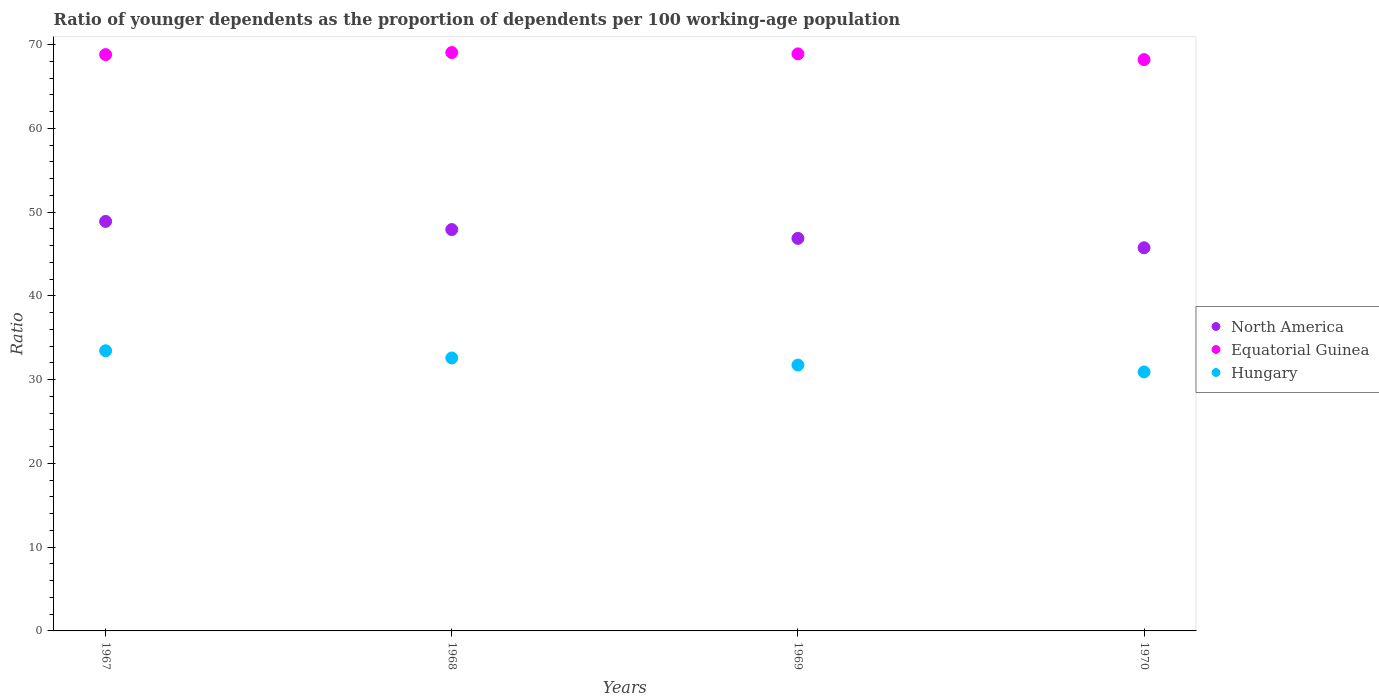How many different coloured dotlines are there?
Offer a very short reply. 3. Is the number of dotlines equal to the number of legend labels?
Ensure brevity in your answer.  Yes. What is the age dependency ratio(young) in North America in 1967?
Make the answer very short. 48.89. Across all years, what is the maximum age dependency ratio(young) in Equatorial Guinea?
Ensure brevity in your answer.  69.04. Across all years, what is the minimum age dependency ratio(young) in Equatorial Guinea?
Offer a very short reply. 68.2. In which year was the age dependency ratio(young) in Equatorial Guinea maximum?
Your response must be concise. 1968. What is the total age dependency ratio(young) in North America in the graph?
Provide a succinct answer. 189.4. What is the difference between the age dependency ratio(young) in Equatorial Guinea in 1967 and that in 1970?
Provide a succinct answer. 0.6. What is the difference between the age dependency ratio(young) in Equatorial Guinea in 1968 and the age dependency ratio(young) in North America in 1970?
Offer a terse response. 23.3. What is the average age dependency ratio(young) in North America per year?
Give a very brief answer. 47.35. In the year 1969, what is the difference between the age dependency ratio(young) in Equatorial Guinea and age dependency ratio(young) in North America?
Give a very brief answer. 22.03. In how many years, is the age dependency ratio(young) in Hungary greater than 62?
Your response must be concise. 0. What is the ratio of the age dependency ratio(young) in North America in 1968 to that in 1970?
Ensure brevity in your answer.  1.05. Is the difference between the age dependency ratio(young) in Equatorial Guinea in 1968 and 1970 greater than the difference between the age dependency ratio(young) in North America in 1968 and 1970?
Make the answer very short. No. What is the difference between the highest and the second highest age dependency ratio(young) in Hungary?
Offer a terse response. 0.86. What is the difference between the highest and the lowest age dependency ratio(young) in North America?
Offer a very short reply. 3.15. Is it the case that in every year, the sum of the age dependency ratio(young) in North America and age dependency ratio(young) in Hungary  is greater than the age dependency ratio(young) in Equatorial Guinea?
Ensure brevity in your answer.  Yes. Is the age dependency ratio(young) in Equatorial Guinea strictly greater than the age dependency ratio(young) in North America over the years?
Provide a succinct answer. Yes. Is the age dependency ratio(young) in Equatorial Guinea strictly less than the age dependency ratio(young) in North America over the years?
Ensure brevity in your answer.  No. Does the graph contain grids?
Offer a very short reply. No. Where does the legend appear in the graph?
Your answer should be very brief. Center right. What is the title of the graph?
Offer a very short reply. Ratio of younger dependents as the proportion of dependents per 100 working-age population. What is the label or title of the X-axis?
Ensure brevity in your answer.  Years. What is the label or title of the Y-axis?
Your answer should be very brief. Ratio. What is the Ratio in North America in 1967?
Provide a succinct answer. 48.89. What is the Ratio in Equatorial Guinea in 1967?
Offer a terse response. 68.8. What is the Ratio in Hungary in 1967?
Offer a terse response. 33.44. What is the Ratio in North America in 1968?
Offer a very short reply. 47.91. What is the Ratio of Equatorial Guinea in 1968?
Provide a succinct answer. 69.04. What is the Ratio in Hungary in 1968?
Your answer should be compact. 32.58. What is the Ratio of North America in 1969?
Provide a short and direct response. 46.86. What is the Ratio in Equatorial Guinea in 1969?
Give a very brief answer. 68.89. What is the Ratio of Hungary in 1969?
Give a very brief answer. 31.74. What is the Ratio of North America in 1970?
Provide a succinct answer. 45.74. What is the Ratio in Equatorial Guinea in 1970?
Your answer should be very brief. 68.2. What is the Ratio in Hungary in 1970?
Your answer should be compact. 30.92. Across all years, what is the maximum Ratio of North America?
Offer a very short reply. 48.89. Across all years, what is the maximum Ratio of Equatorial Guinea?
Provide a succinct answer. 69.04. Across all years, what is the maximum Ratio of Hungary?
Keep it short and to the point. 33.44. Across all years, what is the minimum Ratio of North America?
Make the answer very short. 45.74. Across all years, what is the minimum Ratio of Equatorial Guinea?
Keep it short and to the point. 68.2. Across all years, what is the minimum Ratio of Hungary?
Offer a terse response. 30.92. What is the total Ratio in North America in the graph?
Your response must be concise. 189.4. What is the total Ratio of Equatorial Guinea in the graph?
Your response must be concise. 274.93. What is the total Ratio in Hungary in the graph?
Offer a very short reply. 128.68. What is the difference between the Ratio in North America in 1967 and that in 1968?
Offer a terse response. 0.97. What is the difference between the Ratio in Equatorial Guinea in 1967 and that in 1968?
Offer a very short reply. -0.25. What is the difference between the Ratio in Hungary in 1967 and that in 1968?
Make the answer very short. 0.86. What is the difference between the Ratio in North America in 1967 and that in 1969?
Your response must be concise. 2.03. What is the difference between the Ratio in Equatorial Guinea in 1967 and that in 1969?
Your answer should be very brief. -0.09. What is the difference between the Ratio of Hungary in 1967 and that in 1969?
Offer a very short reply. 1.71. What is the difference between the Ratio in North America in 1967 and that in 1970?
Provide a succinct answer. 3.15. What is the difference between the Ratio in Equatorial Guinea in 1967 and that in 1970?
Your answer should be compact. 0.6. What is the difference between the Ratio in Hungary in 1967 and that in 1970?
Your answer should be compact. 2.53. What is the difference between the Ratio in North America in 1968 and that in 1969?
Keep it short and to the point. 1.05. What is the difference between the Ratio in Equatorial Guinea in 1968 and that in 1969?
Provide a short and direct response. 0.16. What is the difference between the Ratio of Hungary in 1968 and that in 1969?
Your answer should be compact. 0.85. What is the difference between the Ratio in North America in 1968 and that in 1970?
Provide a succinct answer. 2.17. What is the difference between the Ratio in Equatorial Guinea in 1968 and that in 1970?
Provide a succinct answer. 0.84. What is the difference between the Ratio in Hungary in 1968 and that in 1970?
Keep it short and to the point. 1.67. What is the difference between the Ratio of North America in 1969 and that in 1970?
Provide a succinct answer. 1.12. What is the difference between the Ratio in Equatorial Guinea in 1969 and that in 1970?
Give a very brief answer. 0.69. What is the difference between the Ratio in Hungary in 1969 and that in 1970?
Provide a short and direct response. 0.82. What is the difference between the Ratio in North America in 1967 and the Ratio in Equatorial Guinea in 1968?
Keep it short and to the point. -20.16. What is the difference between the Ratio in North America in 1967 and the Ratio in Hungary in 1968?
Your response must be concise. 16.3. What is the difference between the Ratio in Equatorial Guinea in 1967 and the Ratio in Hungary in 1968?
Provide a succinct answer. 36.21. What is the difference between the Ratio in North America in 1967 and the Ratio in Equatorial Guinea in 1969?
Keep it short and to the point. -20. What is the difference between the Ratio in North America in 1967 and the Ratio in Hungary in 1969?
Offer a very short reply. 17.15. What is the difference between the Ratio in Equatorial Guinea in 1967 and the Ratio in Hungary in 1969?
Make the answer very short. 37.06. What is the difference between the Ratio of North America in 1967 and the Ratio of Equatorial Guinea in 1970?
Your answer should be compact. -19.31. What is the difference between the Ratio of North America in 1967 and the Ratio of Hungary in 1970?
Your answer should be compact. 17.97. What is the difference between the Ratio of Equatorial Guinea in 1967 and the Ratio of Hungary in 1970?
Offer a terse response. 37.88. What is the difference between the Ratio in North America in 1968 and the Ratio in Equatorial Guinea in 1969?
Keep it short and to the point. -20.97. What is the difference between the Ratio in North America in 1968 and the Ratio in Hungary in 1969?
Your response must be concise. 16.18. What is the difference between the Ratio of Equatorial Guinea in 1968 and the Ratio of Hungary in 1969?
Make the answer very short. 37.31. What is the difference between the Ratio in North America in 1968 and the Ratio in Equatorial Guinea in 1970?
Give a very brief answer. -20.29. What is the difference between the Ratio in North America in 1968 and the Ratio in Hungary in 1970?
Make the answer very short. 17. What is the difference between the Ratio in Equatorial Guinea in 1968 and the Ratio in Hungary in 1970?
Offer a very short reply. 38.13. What is the difference between the Ratio of North America in 1969 and the Ratio of Equatorial Guinea in 1970?
Offer a terse response. -21.34. What is the difference between the Ratio of North America in 1969 and the Ratio of Hungary in 1970?
Ensure brevity in your answer.  15.94. What is the difference between the Ratio of Equatorial Guinea in 1969 and the Ratio of Hungary in 1970?
Provide a short and direct response. 37.97. What is the average Ratio in North America per year?
Ensure brevity in your answer.  47.35. What is the average Ratio in Equatorial Guinea per year?
Your answer should be compact. 68.73. What is the average Ratio of Hungary per year?
Keep it short and to the point. 32.17. In the year 1967, what is the difference between the Ratio in North America and Ratio in Equatorial Guinea?
Give a very brief answer. -19.91. In the year 1967, what is the difference between the Ratio of North America and Ratio of Hungary?
Keep it short and to the point. 15.44. In the year 1967, what is the difference between the Ratio of Equatorial Guinea and Ratio of Hungary?
Make the answer very short. 35.35. In the year 1968, what is the difference between the Ratio in North America and Ratio in Equatorial Guinea?
Make the answer very short. -21.13. In the year 1968, what is the difference between the Ratio of North America and Ratio of Hungary?
Your answer should be very brief. 15.33. In the year 1968, what is the difference between the Ratio in Equatorial Guinea and Ratio in Hungary?
Ensure brevity in your answer.  36.46. In the year 1969, what is the difference between the Ratio of North America and Ratio of Equatorial Guinea?
Offer a very short reply. -22.03. In the year 1969, what is the difference between the Ratio of North America and Ratio of Hungary?
Provide a short and direct response. 15.12. In the year 1969, what is the difference between the Ratio of Equatorial Guinea and Ratio of Hungary?
Your answer should be very brief. 37.15. In the year 1970, what is the difference between the Ratio of North America and Ratio of Equatorial Guinea?
Ensure brevity in your answer.  -22.46. In the year 1970, what is the difference between the Ratio of North America and Ratio of Hungary?
Your answer should be compact. 14.82. In the year 1970, what is the difference between the Ratio in Equatorial Guinea and Ratio in Hungary?
Your answer should be compact. 37.28. What is the ratio of the Ratio in North America in 1967 to that in 1968?
Give a very brief answer. 1.02. What is the ratio of the Ratio of Equatorial Guinea in 1967 to that in 1968?
Keep it short and to the point. 1. What is the ratio of the Ratio in Hungary in 1967 to that in 1968?
Keep it short and to the point. 1.03. What is the ratio of the Ratio in North America in 1967 to that in 1969?
Offer a terse response. 1.04. What is the ratio of the Ratio in Hungary in 1967 to that in 1969?
Offer a very short reply. 1.05. What is the ratio of the Ratio in North America in 1967 to that in 1970?
Your answer should be very brief. 1.07. What is the ratio of the Ratio in Equatorial Guinea in 1967 to that in 1970?
Give a very brief answer. 1.01. What is the ratio of the Ratio in Hungary in 1967 to that in 1970?
Your answer should be compact. 1.08. What is the ratio of the Ratio of North America in 1968 to that in 1969?
Provide a short and direct response. 1.02. What is the ratio of the Ratio in Hungary in 1968 to that in 1969?
Give a very brief answer. 1.03. What is the ratio of the Ratio of North America in 1968 to that in 1970?
Your response must be concise. 1.05. What is the ratio of the Ratio in Equatorial Guinea in 1968 to that in 1970?
Your answer should be compact. 1.01. What is the ratio of the Ratio of Hungary in 1968 to that in 1970?
Make the answer very short. 1.05. What is the ratio of the Ratio in North America in 1969 to that in 1970?
Your response must be concise. 1.02. What is the ratio of the Ratio in Hungary in 1969 to that in 1970?
Provide a succinct answer. 1.03. What is the difference between the highest and the second highest Ratio of North America?
Provide a short and direct response. 0.97. What is the difference between the highest and the second highest Ratio in Equatorial Guinea?
Your answer should be compact. 0.16. What is the difference between the highest and the second highest Ratio of Hungary?
Give a very brief answer. 0.86. What is the difference between the highest and the lowest Ratio of North America?
Your answer should be compact. 3.15. What is the difference between the highest and the lowest Ratio of Equatorial Guinea?
Offer a very short reply. 0.84. What is the difference between the highest and the lowest Ratio of Hungary?
Provide a short and direct response. 2.53. 